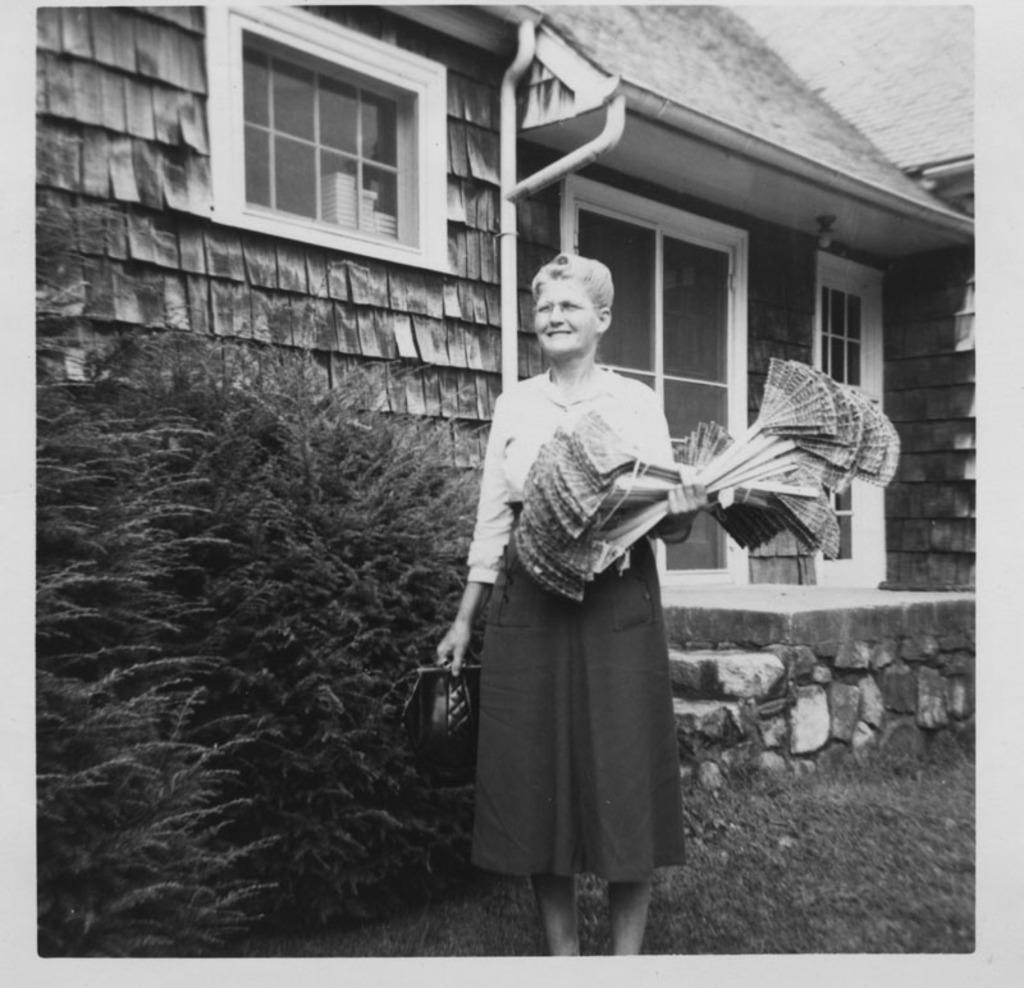In one or two sentences, can you explain what this image depicts? This is a black and white image. In this image we can see there is a lady standing on the surface of the grass and she is holding some object in her hand, inside her there are some trees and building. 